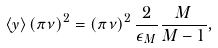Convert formula to latex. <formula><loc_0><loc_0><loc_500><loc_500>\left \langle y \right \rangle \left ( \pi \nu \right ) ^ { 2 } = \left ( \pi \nu \right ) ^ { 2 } \frac { 2 } { \epsilon _ { M } } \frac { M } { M - 1 } ,</formula> 